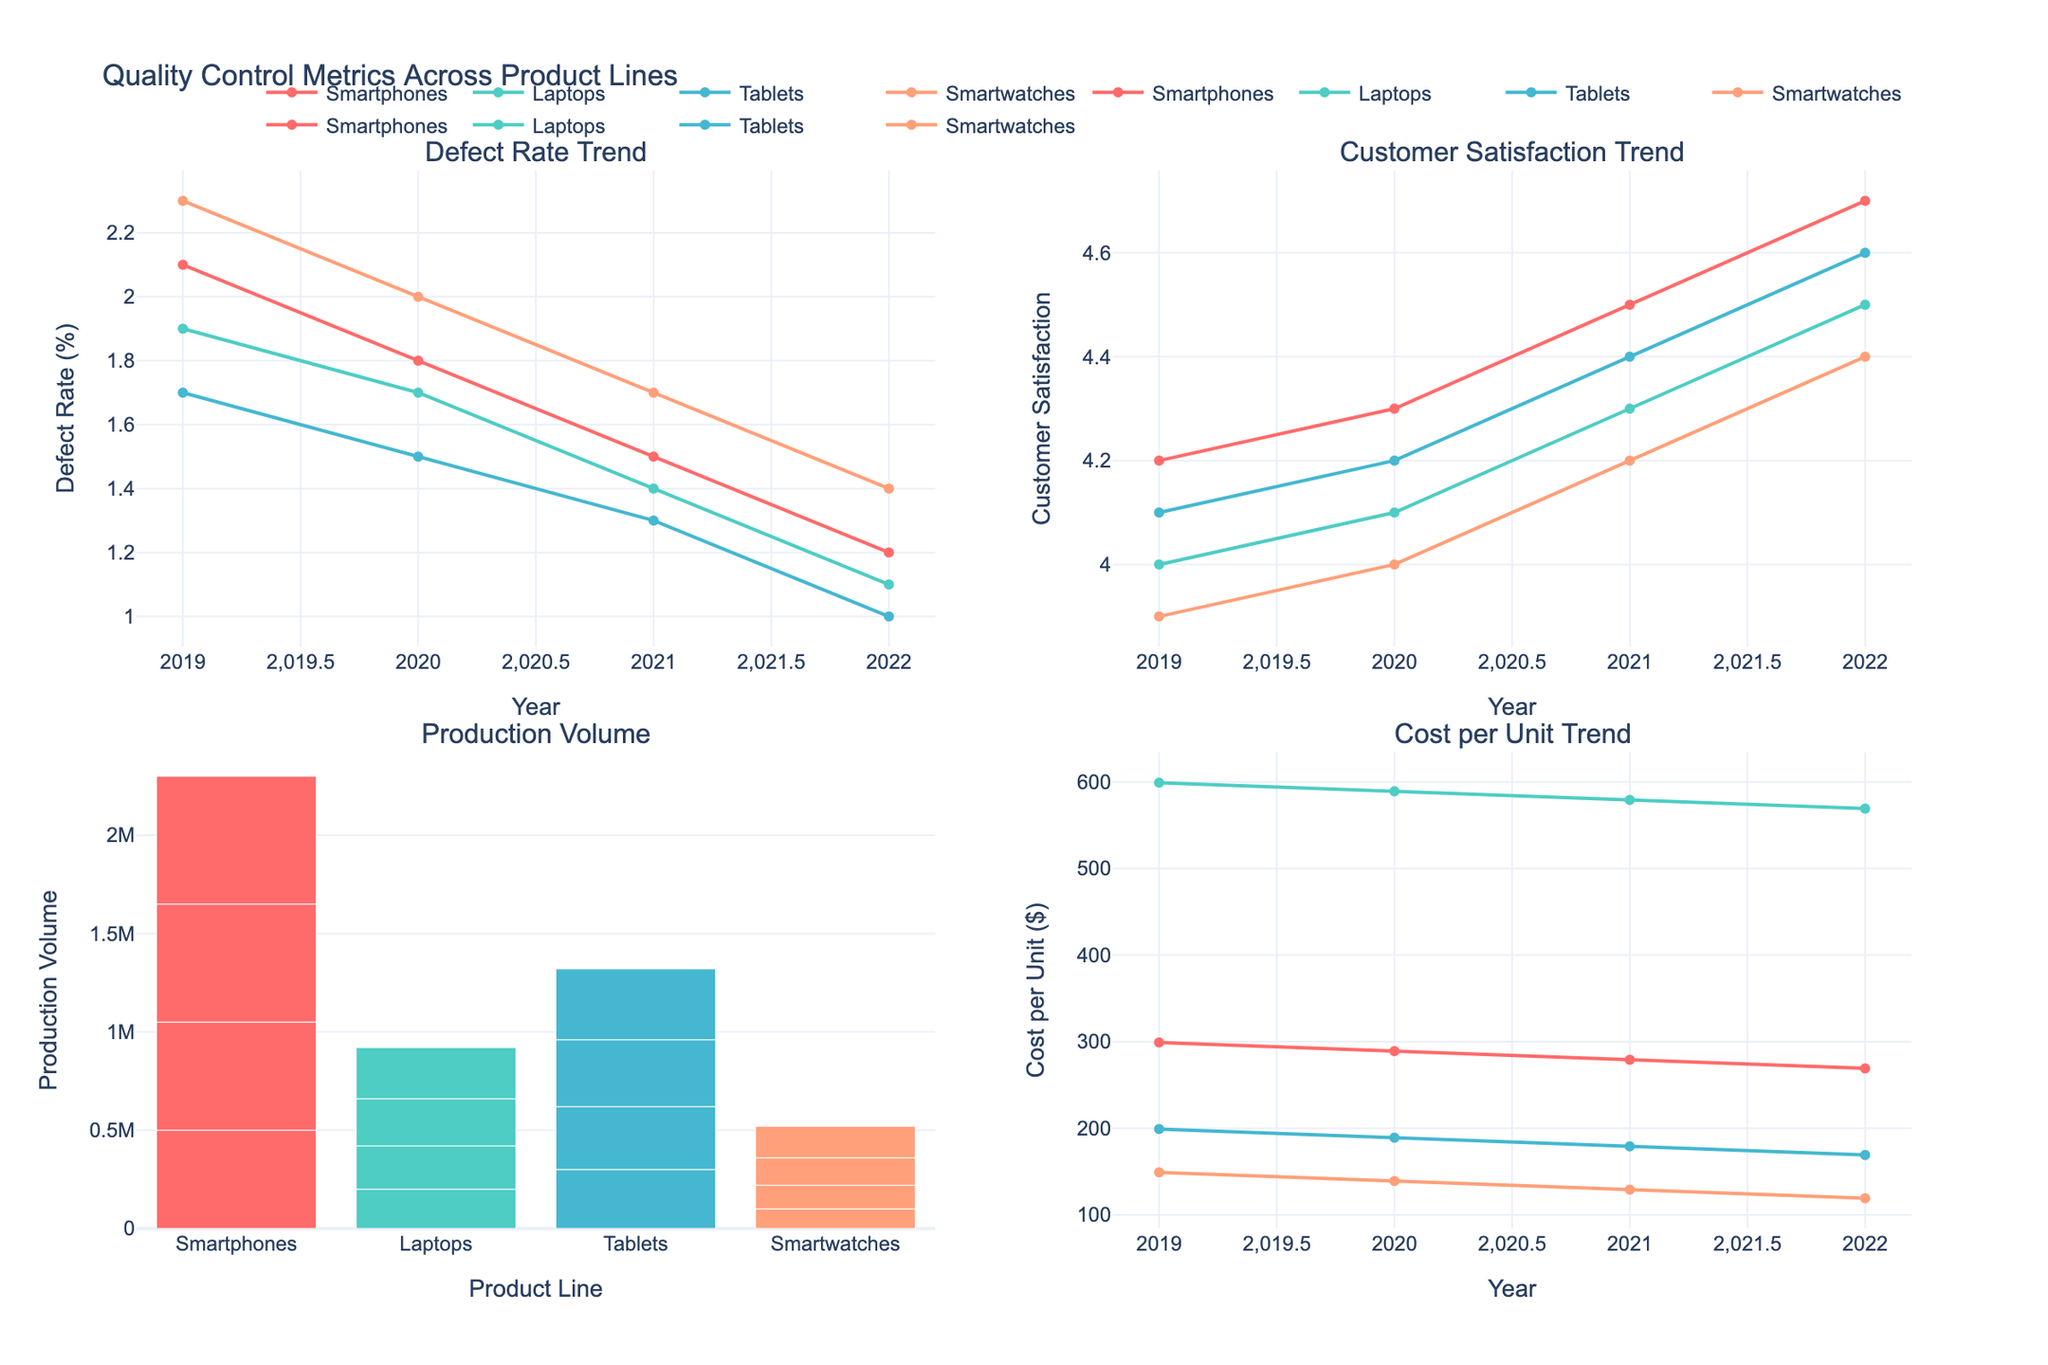What is the trend of the defect rate for Smartphones from 2019 to 2022? To answer this, look at the "Defect Rate Trend" plot and the line corresponding to Smartphones. The defect rate decreases consistently from 2.1% in 2019 to 1.2% in 2022.
Answer: Decreasing Which product line had the highest customer satisfaction in 2022? Look at the "Customer Satisfaction Trend" plot and check the customer satisfaction values for all lines in 2022. Tablets had the highest customer satisfaction at 4.6.
Answer: Tablets How did the production volume for Smartwatches change from 2019 to 2022? Refer to the "Production Volume" plot. For Smartwatches, production volume increased from 100,000 units in 2019 to 160,000 units in 2022.
Answer: Increased Which product line showed the lowest cost per unit in 2022? Look at the "Cost per Unit Trend" plot and compare the values for all product lines in 2022. Smartwatches had the lowest cost per unit at $119.
Answer: Smartwatches By how much did the defect rate for Laptops decrease from 2019 to 2022? Observe the "Defect Rate Trend" plot for Laptops. The defect rate decreased from 1.9% in 2019 to 1.1% in 2022. Subtract 1.1 from 1.9: 1.9% - 1.1% = 0.8%.
Answer: 0.8% Which product line saw the most significant improvement in customer satisfaction between 2019 and 2022? Refer to the "Customer Satisfaction Trend" plot. The improvement can be calculated by subtracting the customer satisfaction in 2019 from the value in 2022 for each product line. Smartwatches improved from 3.9 to 4.4 (0.5), Smartphones from 4.2 to 4.7 (0.5), Laptops from 4.0 to 4.5 (0.5), and Tablets from 4.1 to 4.6 (0.5). Hence, all lines improved equally.
Answer: All equally Comparing the cost per unit trend, which product line showed the greatest cost reduction from 2019 to 2022? Look at the "Cost per Unit Trend" plot and calculate the differences for each product line between 2019 and 2022: Smartphones (299 - 269 = 30), Laptops (599 - 569 = 30), Tablets (199 - 169 = 30), Smartwatches (149 - 119 = 30). All showed the same reduction of $30.
Answer: All equally What is the average defect rate for Tablets across the years 2019 to 2022? Refer to the "Defect Rate Trend" plot for Tablets. Sum the defect rates for each year (1.7% + 1.5% + 1.3% + 1.0%) equals to 5.5. Divide by 4 years: 5.5 / 4 = 1.375%.
Answer: 1.375% Which product line had the highest production volume in total over the four years? To determine this, look at the "Production Volume" plot and sum the production volumes for all years for each product line. Smartphones (500,000 + 550,000 + 600,000 + 650,000 = 2,300,000), Laptops (200,000 + 220,000 + 240,000 + 260,000 = 920,000), Tablets (300,000 + 320,000 + 340,000 + 360,000 = 1,320,000), Smartwatches (100,000 + 120,000 + 140,000 + 160,000 = 520,000). Smartphones had the highest total production volume.
Answer: Smartphones 